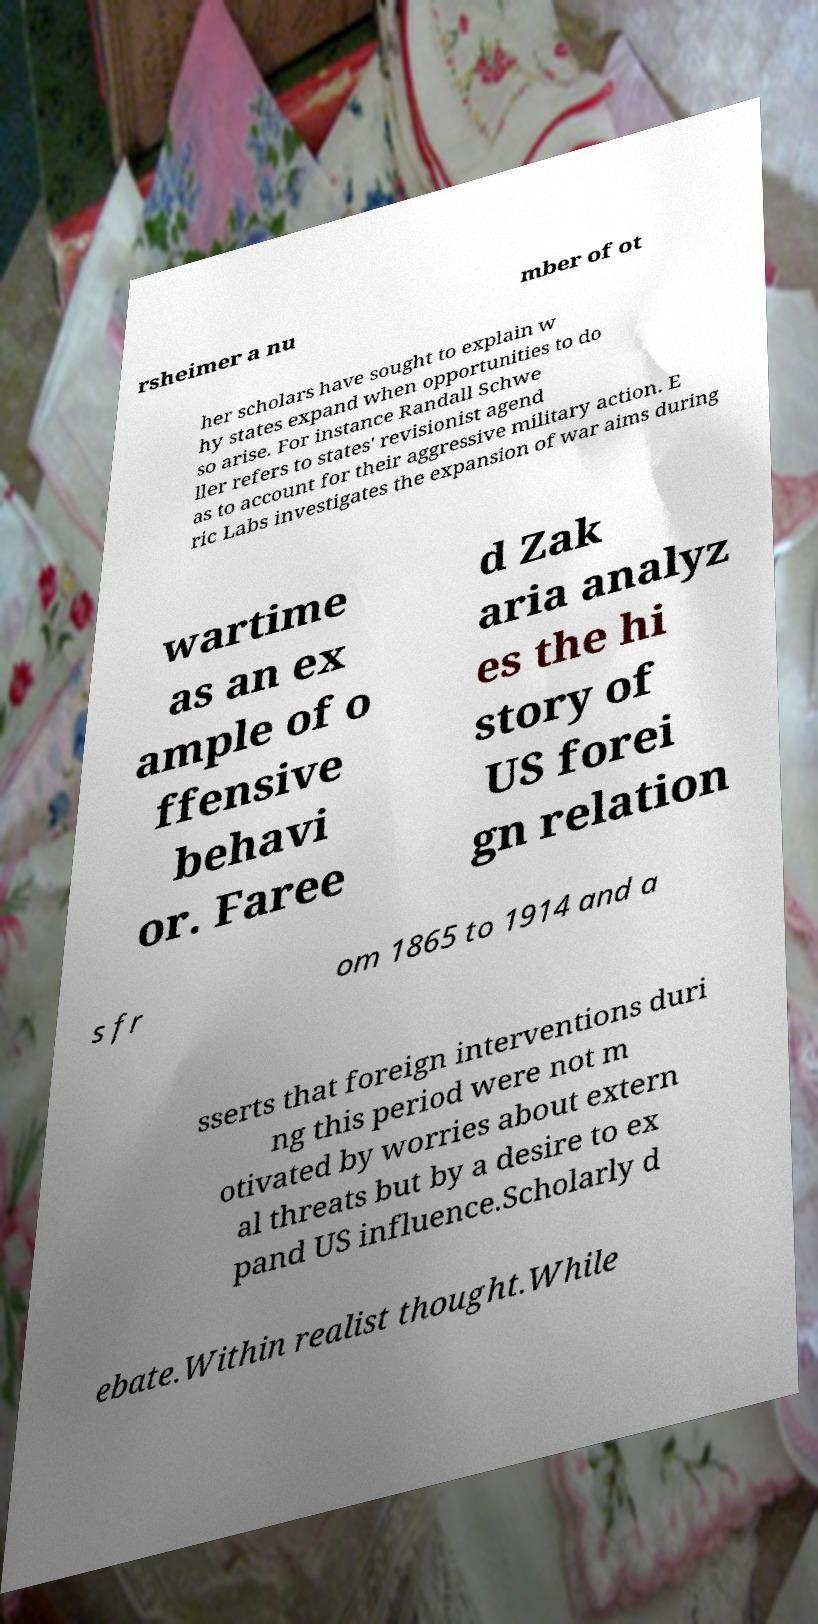I need the written content from this picture converted into text. Can you do that? rsheimer a nu mber of ot her scholars have sought to explain w hy states expand when opportunities to do so arise. For instance Randall Schwe ller refers to states' revisionist agend as to account for their aggressive military action. E ric Labs investigates the expansion of war aims during wartime as an ex ample of o ffensive behavi or. Faree d Zak aria analyz es the hi story of US forei gn relation s fr om 1865 to 1914 and a sserts that foreign interventions duri ng this period were not m otivated by worries about extern al threats but by a desire to ex pand US influence.Scholarly d ebate.Within realist thought.While 